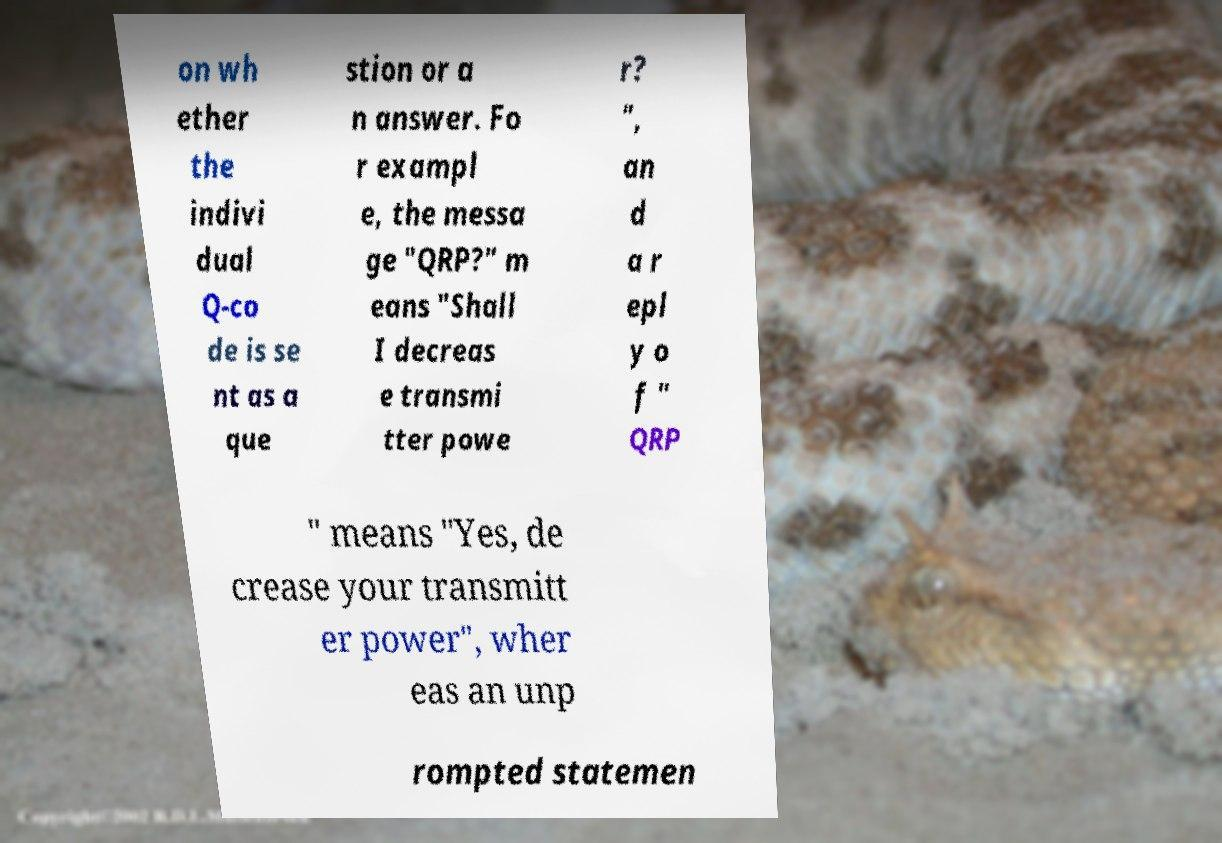What messages or text are displayed in this image? I need them in a readable, typed format. on wh ether the indivi dual Q-co de is se nt as a que stion or a n answer. Fo r exampl e, the messa ge "QRP?" m eans "Shall I decreas e transmi tter powe r? ", an d a r epl y o f " QRP " means "Yes, de crease your transmitt er power", wher eas an unp rompted statemen 